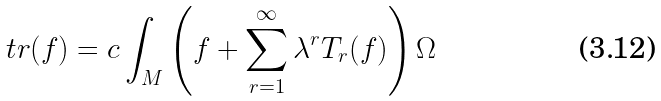<formula> <loc_0><loc_0><loc_500><loc_500>\ t r ( f ) = c \int _ { M } \left ( f + \sum _ { r = 1 } ^ { \infty } \lambda ^ { r } T _ { r } ( f ) \right ) \Omega</formula> 